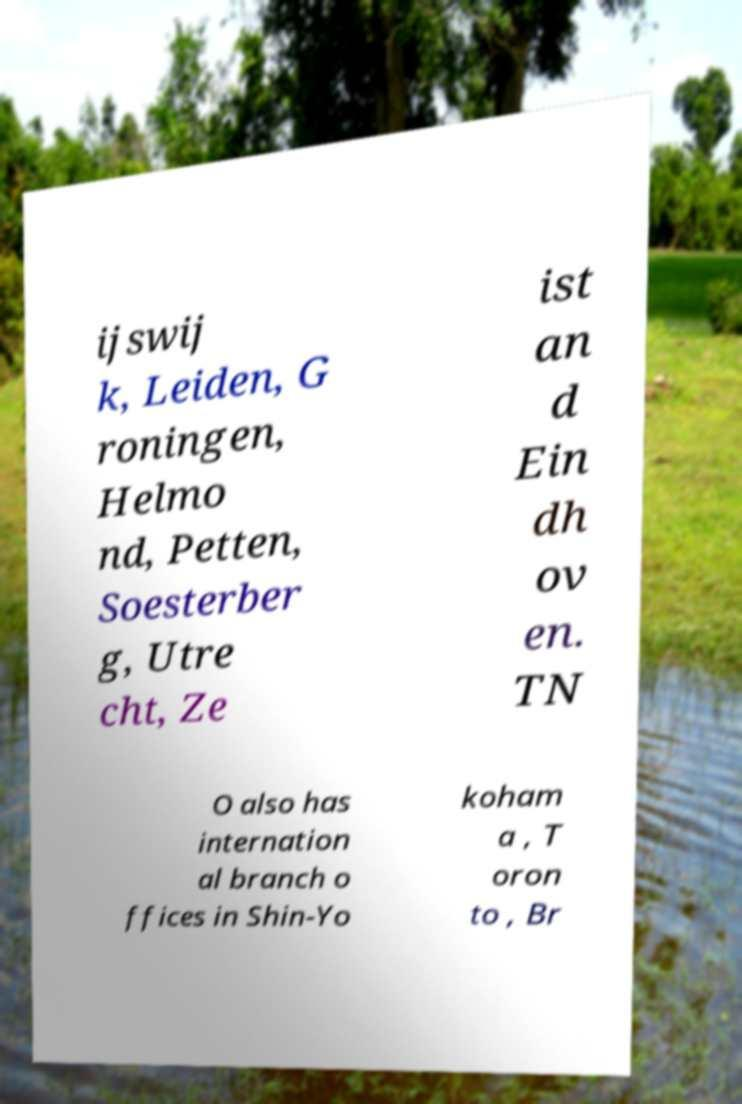Please read and relay the text visible in this image. What does it say? ijswij k, Leiden, G roningen, Helmo nd, Petten, Soesterber g, Utre cht, Ze ist an d Ein dh ov en. TN O also has internation al branch o ffices in Shin-Yo koham a , T oron to , Br 